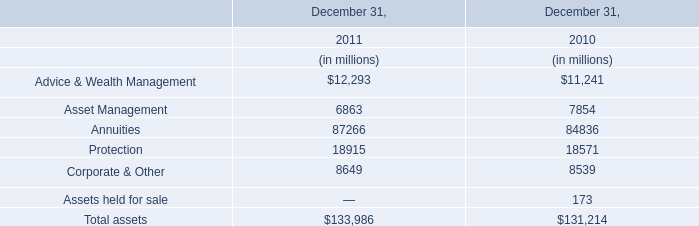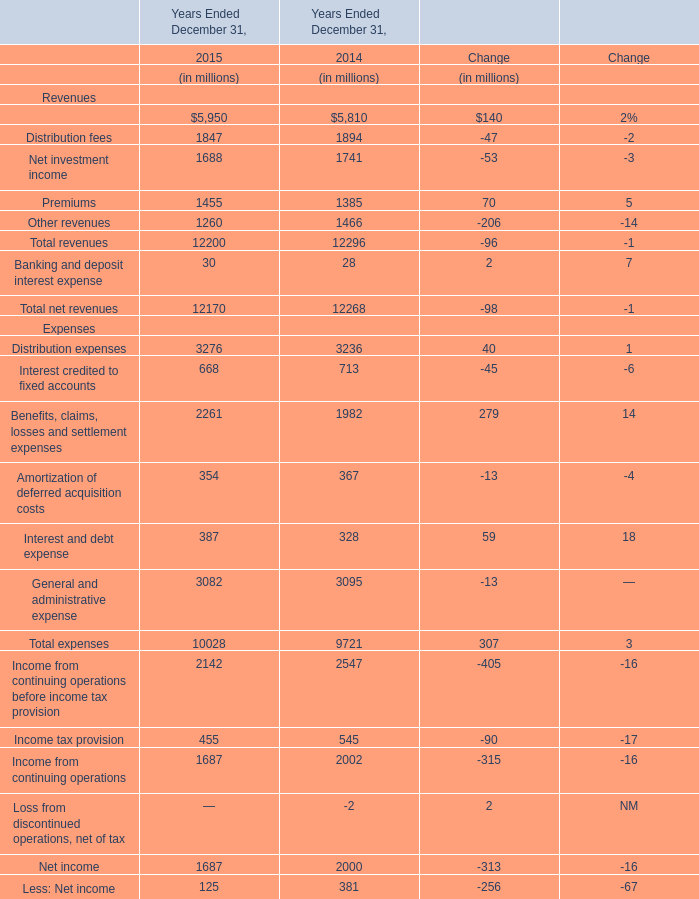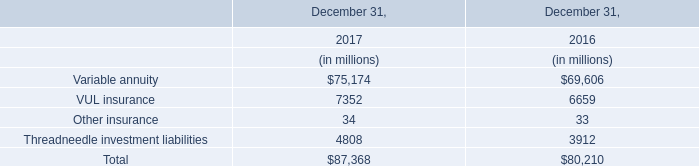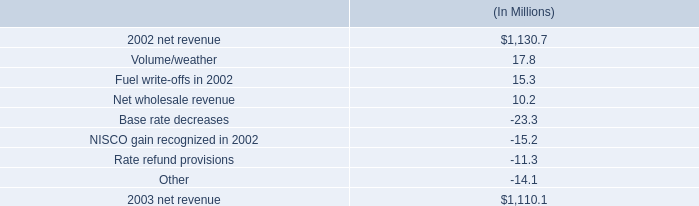what is the growth rate in net revenue in 2003 for entergy gulf states , inc.? 
Computations: ((1110.1 - 1130.7) / 1130.7)
Answer: -0.01822. 